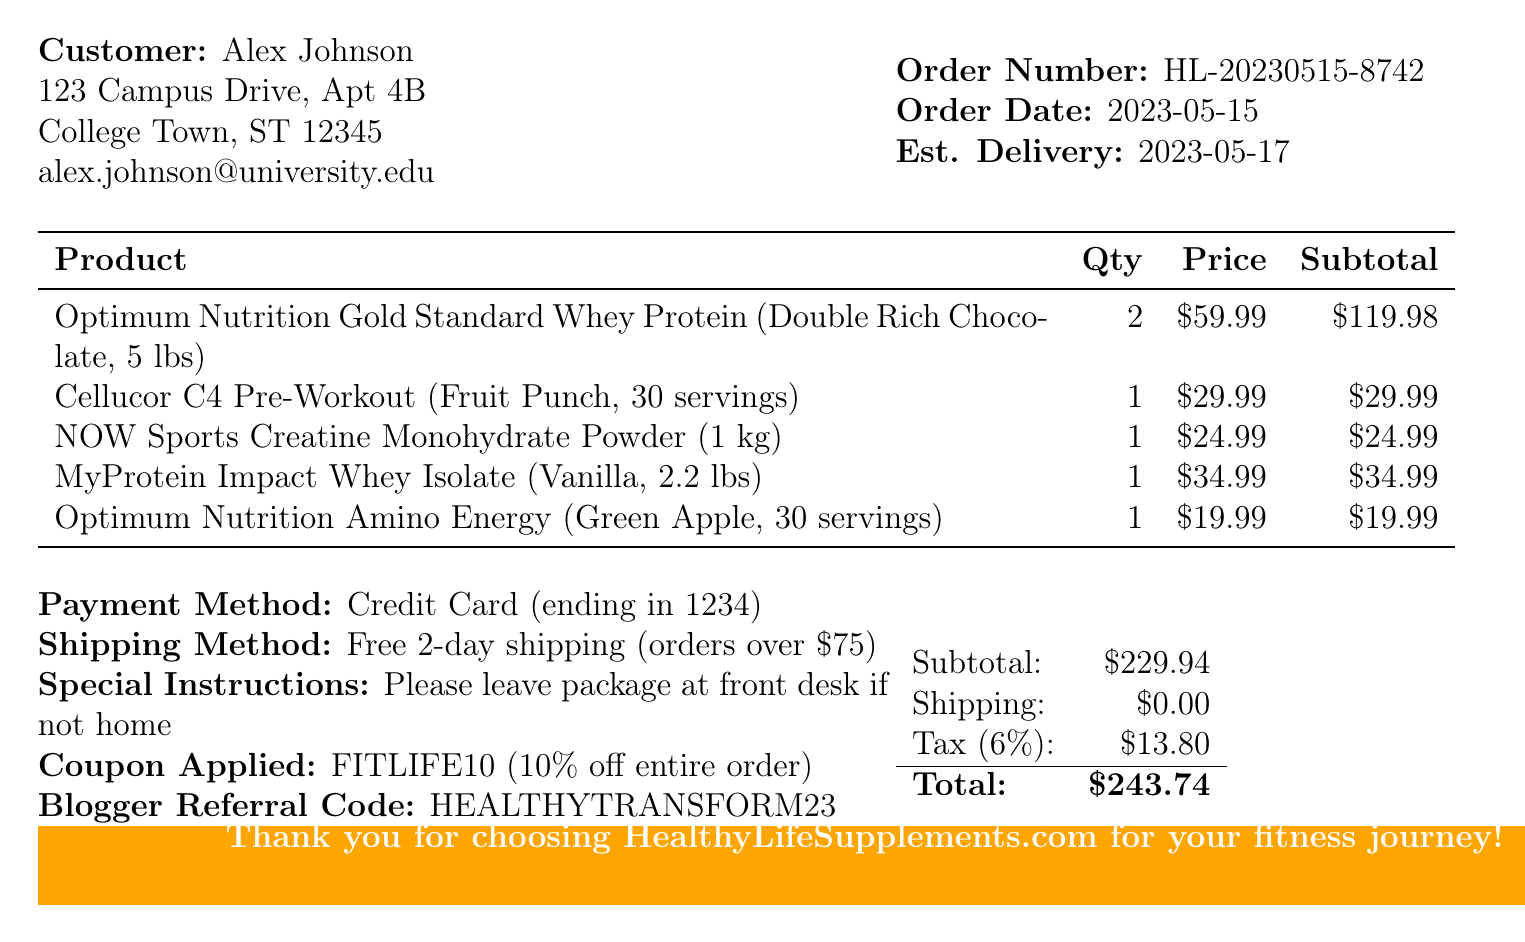What is the order number? The order number appears in the document as HL-20230515-8742.
Answer: HL-20230515-8742 What is the subtotal of the order? The subtotal is directly listed in the document before tax and shipping costs, which is $229.94.
Answer: $229.94 Who is the customer? The customer's name is mentioned at the top of the document as Alex Johnson.
Answer: Alex Johnson What is the estimated delivery date? The estimated delivery date is specified in the document as 2023-05-17.
Answer: 2023-05-17 How many loyalty points were earned? The number of loyalty points earned is stated in the document, which is 244.
Answer: 244 What shipping method was selected? The shipping method is listed in the document as Free 2-day shipping (orders over $75).
Answer: Free 2-day shipping (orders over $75) What coupon was applied to the order? The document mentions the coupon code applied as FITLIFE10, which gives a 10% discount.
Answer: FITLIFE10 How many items were ordered in total? By counting the item details listed in the document, a total of five items were ordered.
Answer: 5 What payment method was used? The payment method is specified in the document as Credit Card (ending in 1234).
Answer: Credit Card (ending in 1234) 